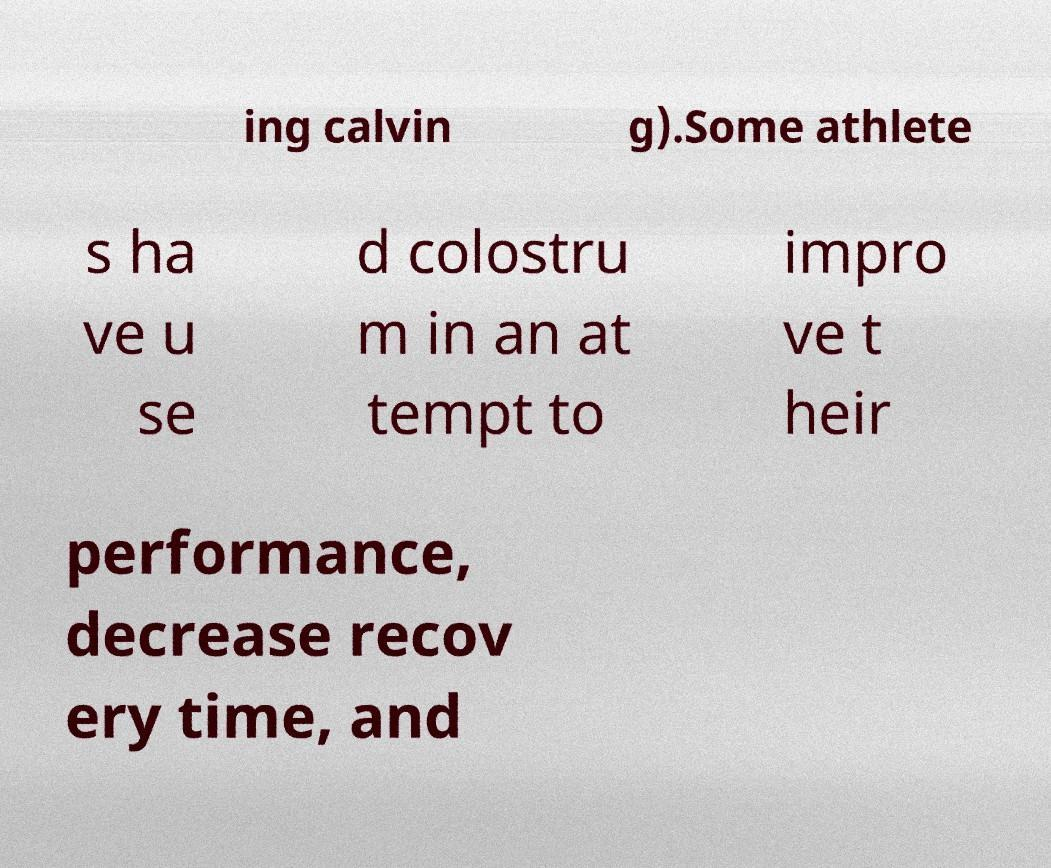For documentation purposes, I need the text within this image transcribed. Could you provide that? ing calvin g).Some athlete s ha ve u se d colostru m in an at tempt to impro ve t heir performance, decrease recov ery time, and 